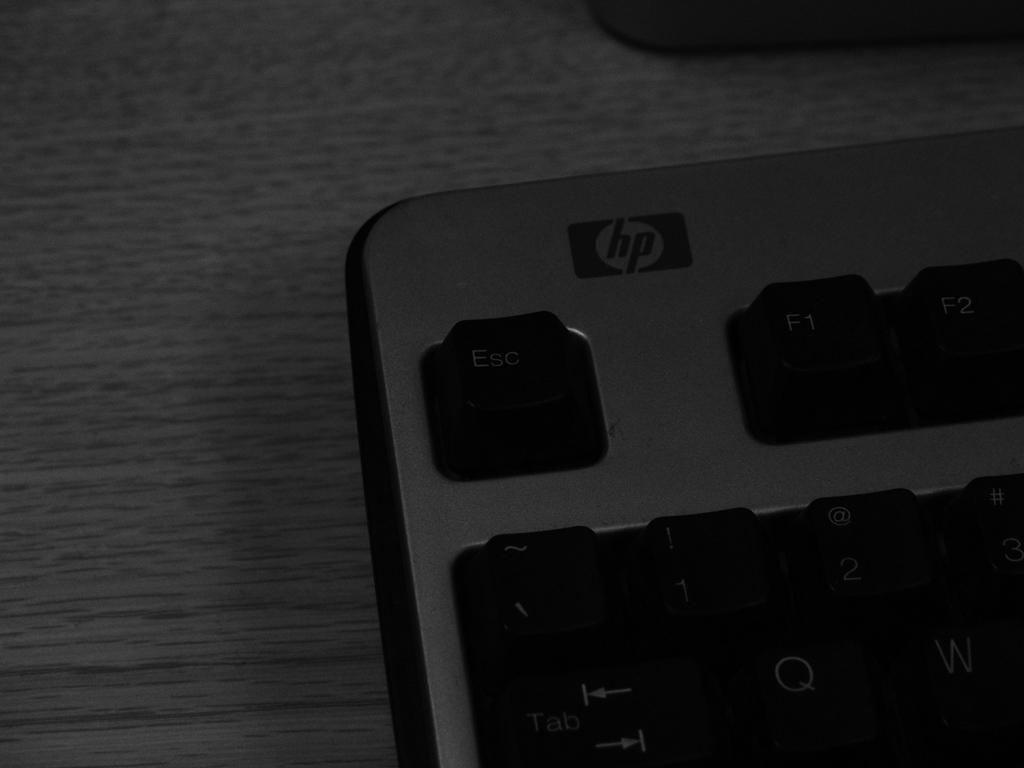What letter is at the top of the keyboard?
Provide a short and direct response. Hp. What brand is it?
Provide a succinct answer. Hp. 